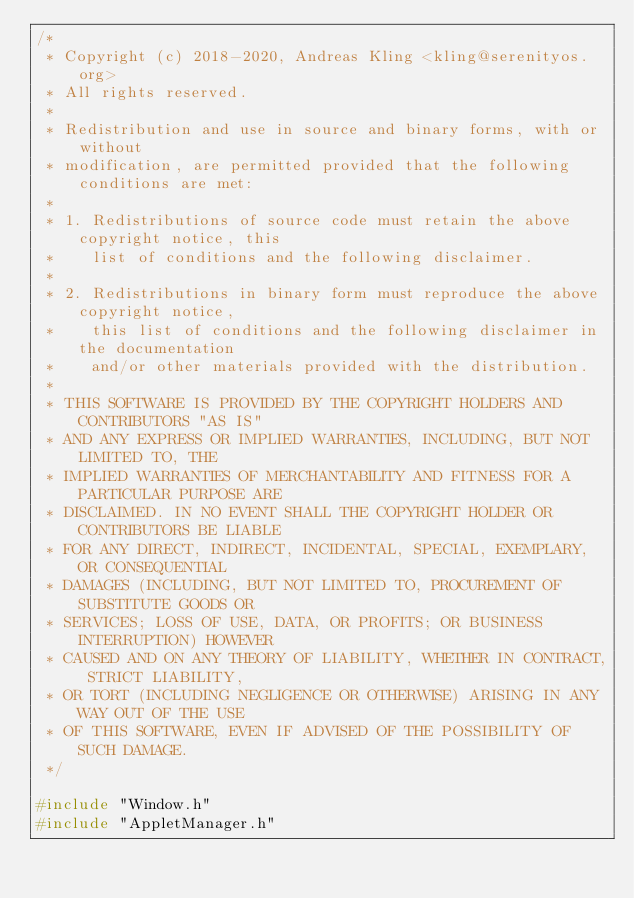<code> <loc_0><loc_0><loc_500><loc_500><_C++_>/*
 * Copyright (c) 2018-2020, Andreas Kling <kling@serenityos.org>
 * All rights reserved.
 *
 * Redistribution and use in source and binary forms, with or without
 * modification, are permitted provided that the following conditions are met:
 *
 * 1. Redistributions of source code must retain the above copyright notice, this
 *    list of conditions and the following disclaimer.
 *
 * 2. Redistributions in binary form must reproduce the above copyright notice,
 *    this list of conditions and the following disclaimer in the documentation
 *    and/or other materials provided with the distribution.
 *
 * THIS SOFTWARE IS PROVIDED BY THE COPYRIGHT HOLDERS AND CONTRIBUTORS "AS IS"
 * AND ANY EXPRESS OR IMPLIED WARRANTIES, INCLUDING, BUT NOT LIMITED TO, THE
 * IMPLIED WARRANTIES OF MERCHANTABILITY AND FITNESS FOR A PARTICULAR PURPOSE ARE
 * DISCLAIMED. IN NO EVENT SHALL THE COPYRIGHT HOLDER OR CONTRIBUTORS BE LIABLE
 * FOR ANY DIRECT, INDIRECT, INCIDENTAL, SPECIAL, EXEMPLARY, OR CONSEQUENTIAL
 * DAMAGES (INCLUDING, BUT NOT LIMITED TO, PROCUREMENT OF SUBSTITUTE GOODS OR
 * SERVICES; LOSS OF USE, DATA, OR PROFITS; OR BUSINESS INTERRUPTION) HOWEVER
 * CAUSED AND ON ANY THEORY OF LIABILITY, WHETHER IN CONTRACT, STRICT LIABILITY,
 * OR TORT (INCLUDING NEGLIGENCE OR OTHERWISE) ARISING IN ANY WAY OUT OF THE USE
 * OF THIS SOFTWARE, EVEN IF ADVISED OF THE POSSIBILITY OF SUCH DAMAGE.
 */

#include "Window.h"
#include "AppletManager.h"</code> 